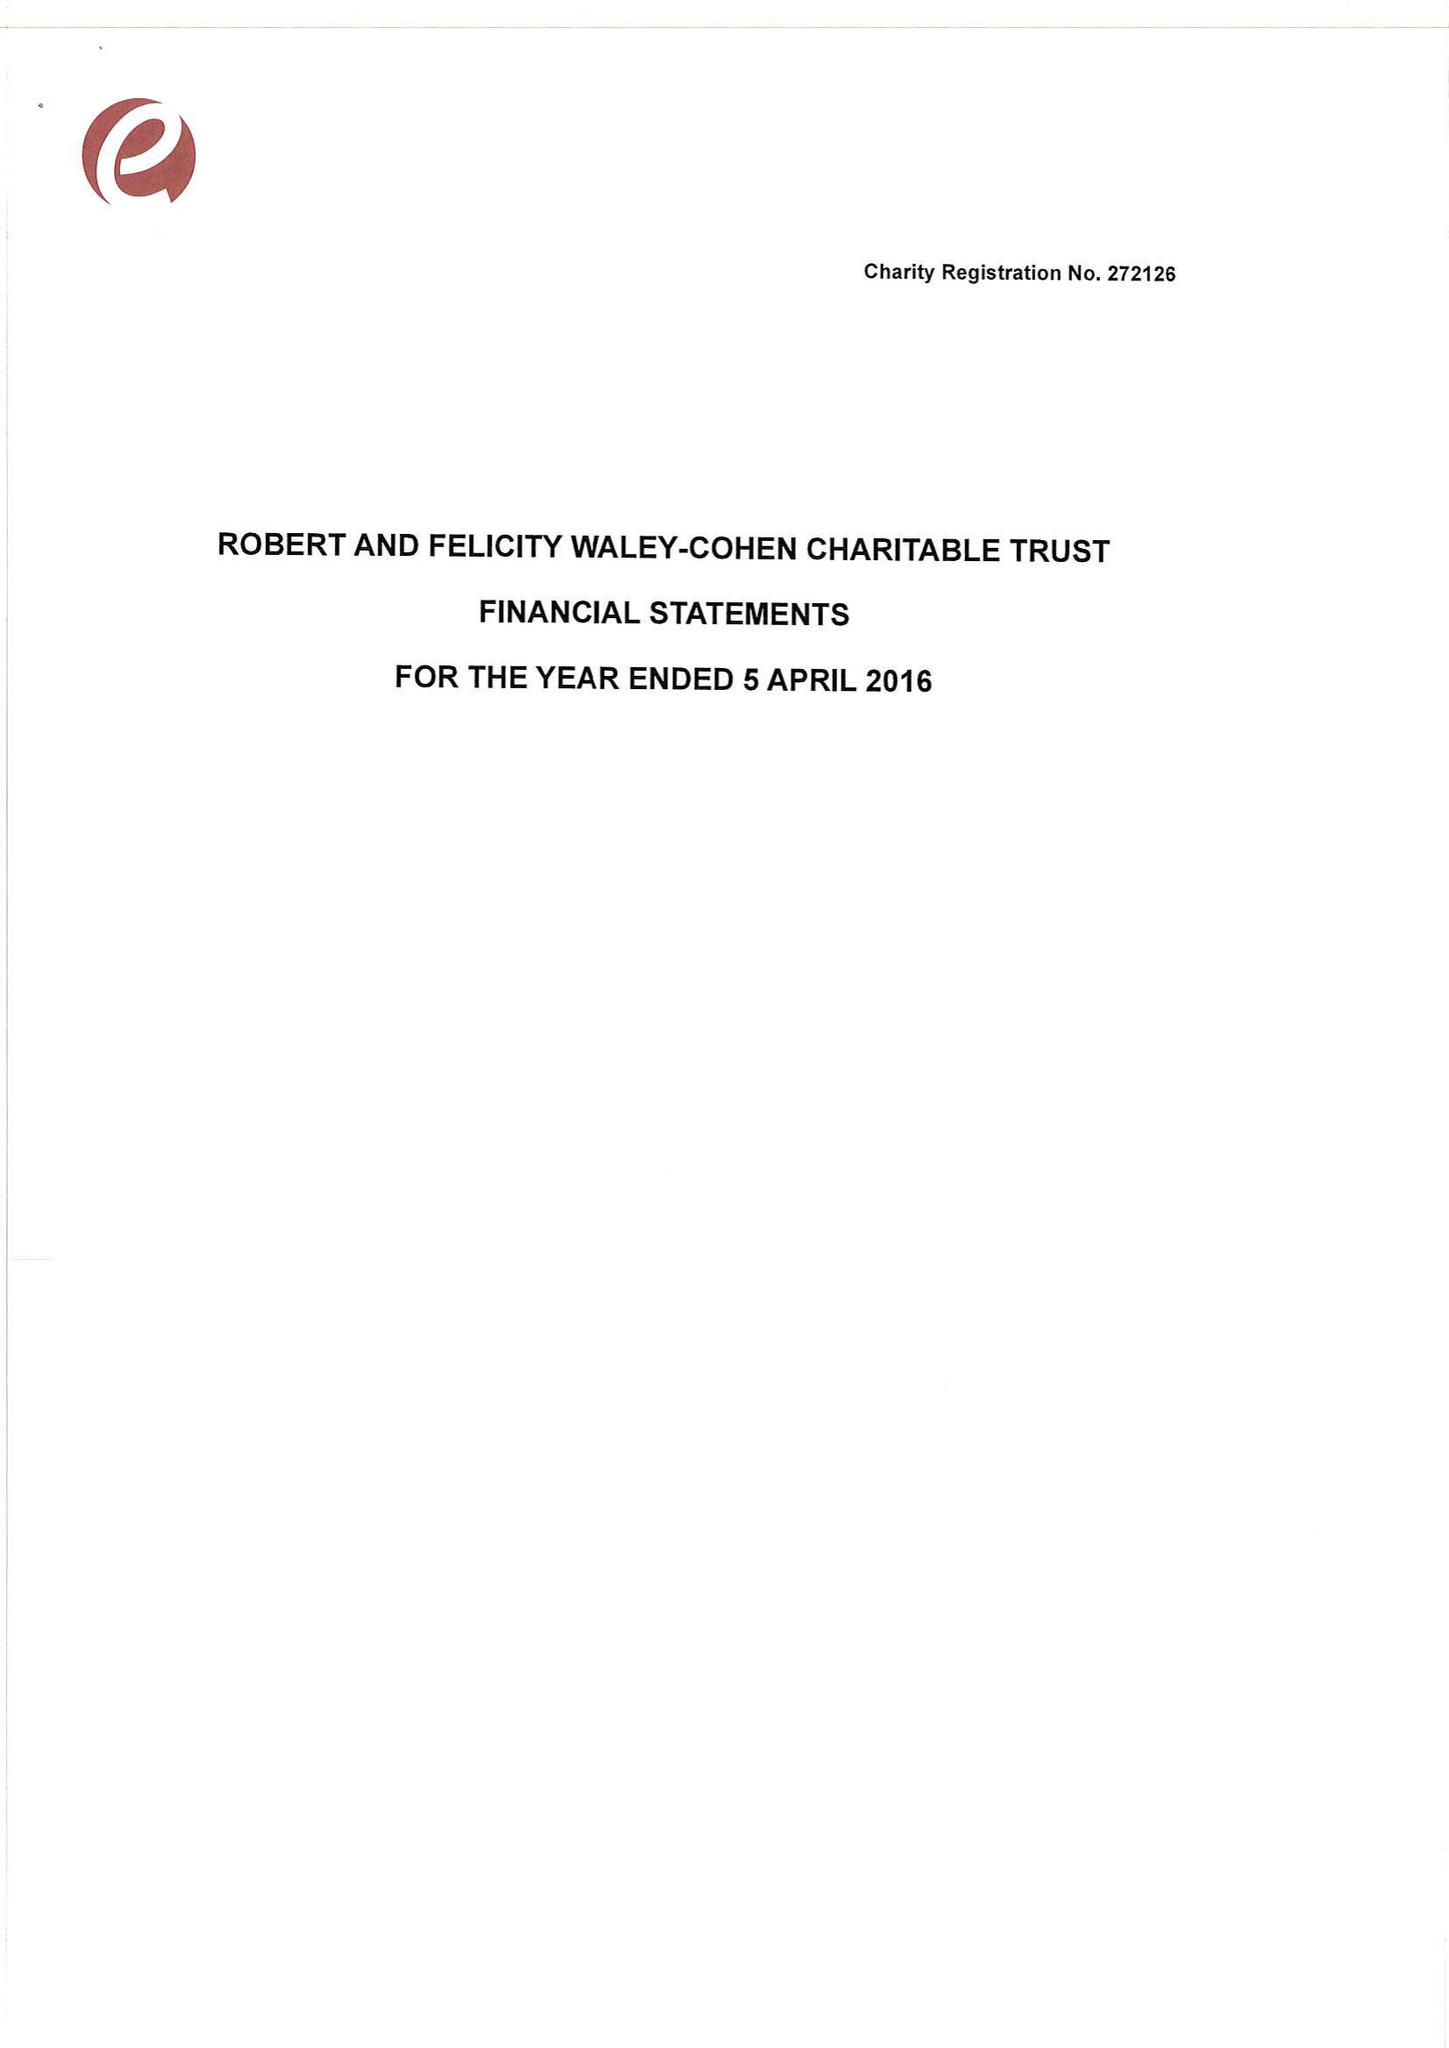What is the value for the report_date?
Answer the question using a single word or phrase. 2016-04-05 